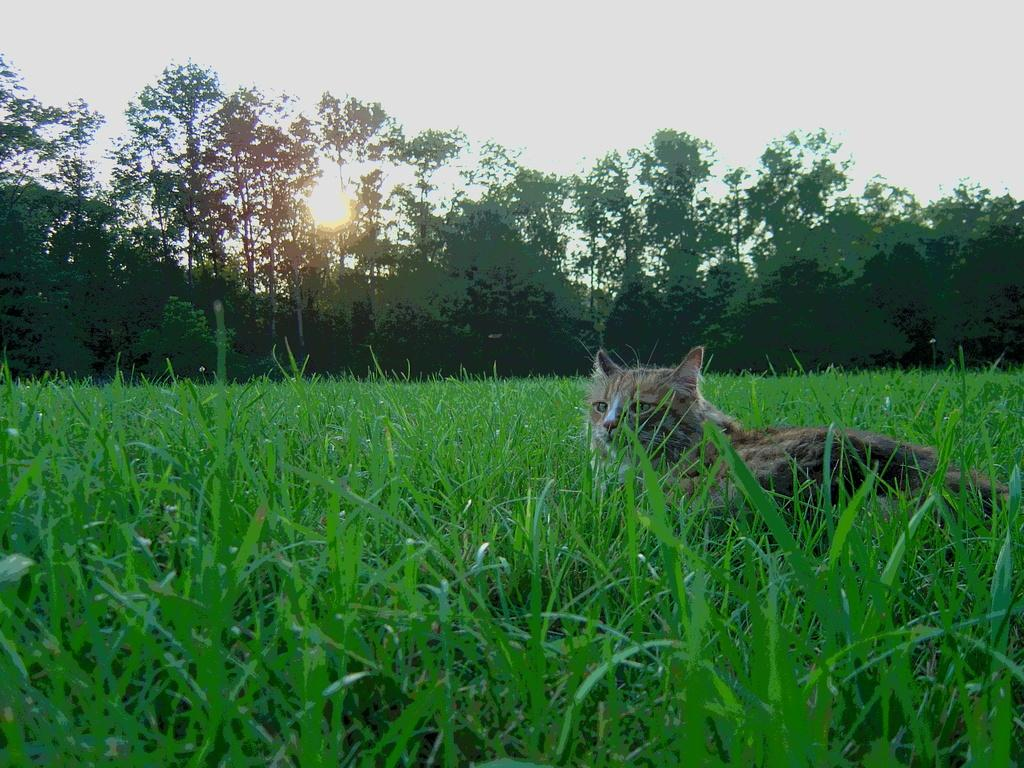What animal can be seen in the image? There is a cat in the image. Where is the cat located? The cat is lying on the grass. What is the cat doing in the image? The cat is looking at something. What can be seen in the background of the image? There are trees and the sky visible in the background of the image. What type of cap is the cat wearing during its voyage with the sister in the image? There is no cap, voyage, or sister present in the image; it features a cat lying on the grass and looking at something. 